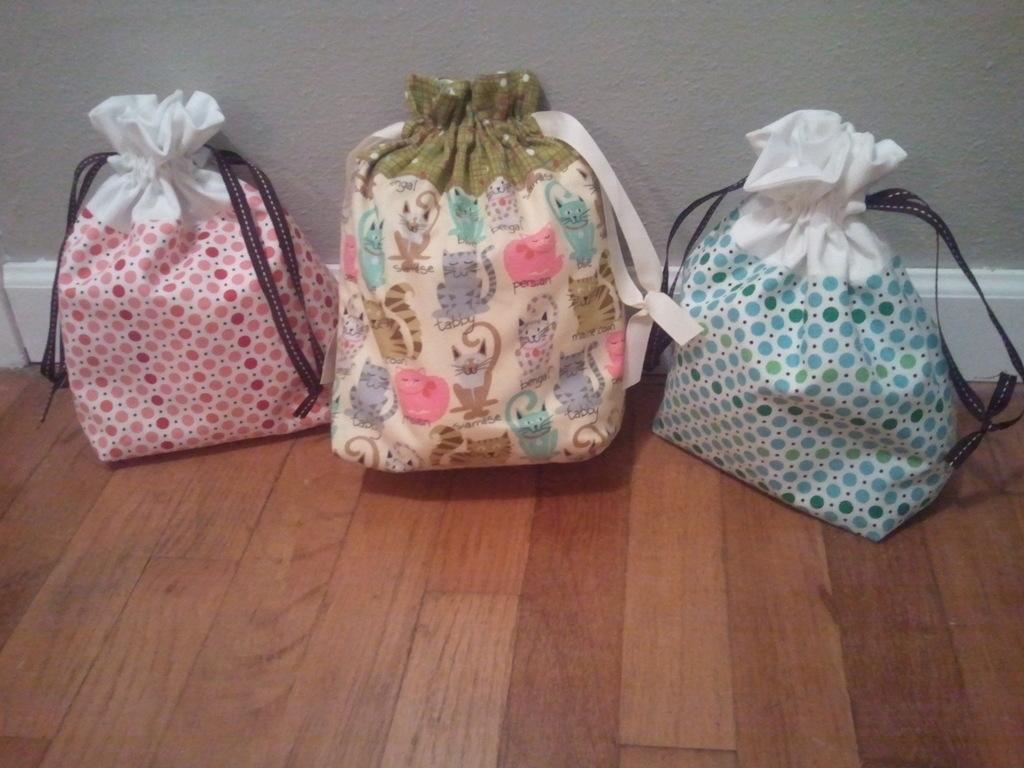Can you describe this image briefly? There are bags in different colors arranged on the wooden floor. In the background, there is white color wall. 